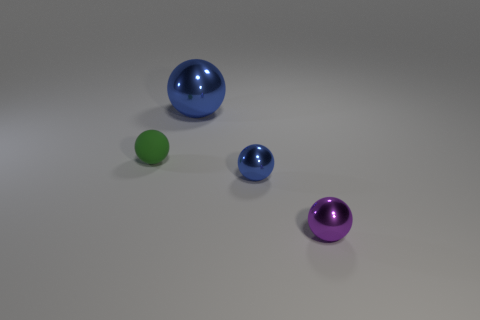There is a sphere behind the matte object; what is its color?
Ensure brevity in your answer.  Blue. Are there any small brown rubber objects that have the same shape as the large blue object?
Give a very brief answer. No. How many green things are either large shiny objects or tiny balls?
Keep it short and to the point. 1. Is there a purple metallic ball that has the same size as the green thing?
Your response must be concise. Yes. What number of large metallic things are there?
Provide a short and direct response. 1. How many tiny objects are brown blocks or purple metallic things?
Make the answer very short. 1. There is a tiny metal ball that is on the left side of the thing that is right of the tiny shiny sphere that is to the left of the tiny purple ball; what color is it?
Ensure brevity in your answer.  Blue. How many other objects are there of the same color as the tiny rubber ball?
Your response must be concise. 0. How many rubber objects are tiny green objects or tiny gray cubes?
Your response must be concise. 1. There is a large metallic sphere on the right side of the small green sphere; does it have the same color as the tiny shiny ball that is on the left side of the small purple metallic thing?
Keep it short and to the point. Yes. 